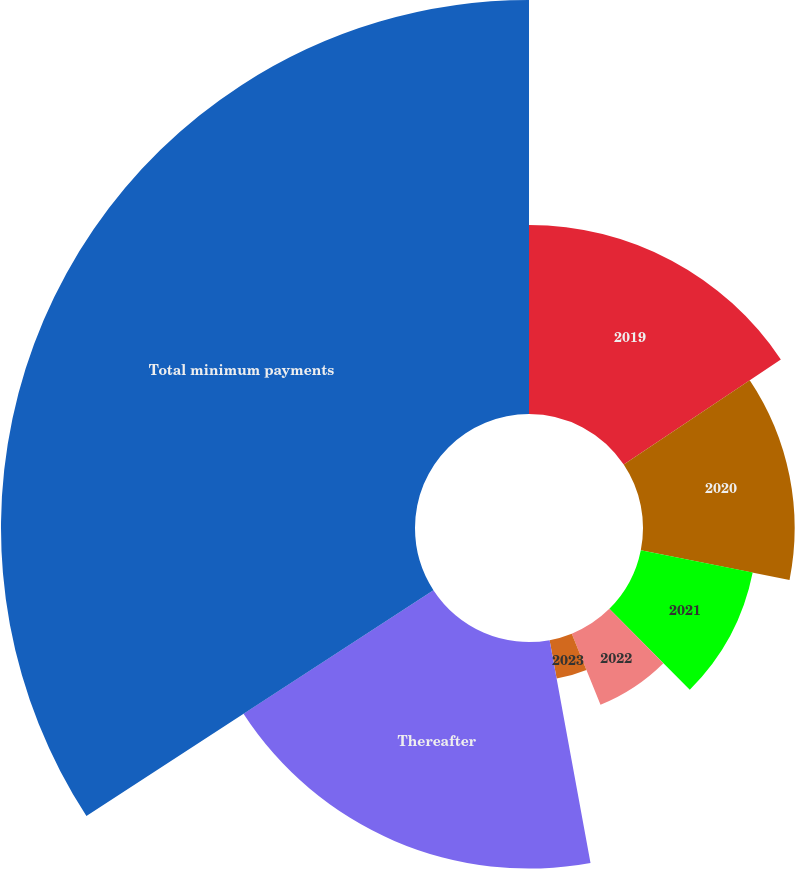Convert chart to OTSL. <chart><loc_0><loc_0><loc_500><loc_500><pie_chart><fcel>2019<fcel>2020<fcel>2021<fcel>2022<fcel>2023<fcel>Thereafter<fcel>Total minimum payments<nl><fcel>15.61%<fcel>12.52%<fcel>9.42%<fcel>6.33%<fcel>3.23%<fcel>18.71%<fcel>34.18%<nl></chart> 